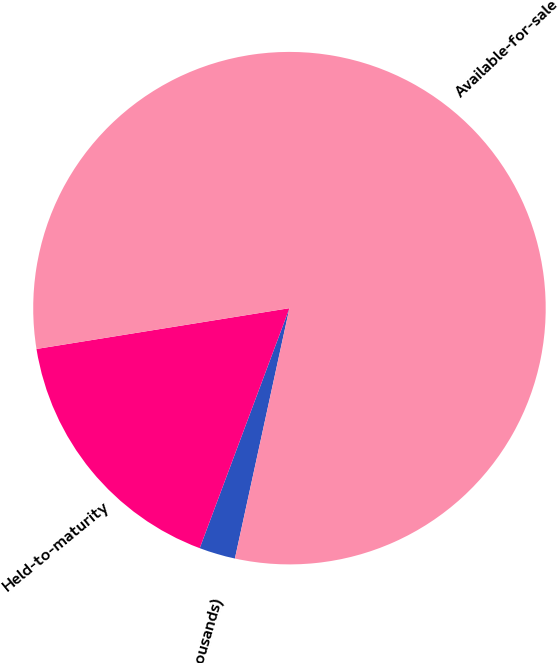Convert chart to OTSL. <chart><loc_0><loc_0><loc_500><loc_500><pie_chart><fcel>(In thousands)<fcel>Held-to-maturity<fcel>Available-for-sale<nl><fcel>2.28%<fcel>16.76%<fcel>80.96%<nl></chart> 